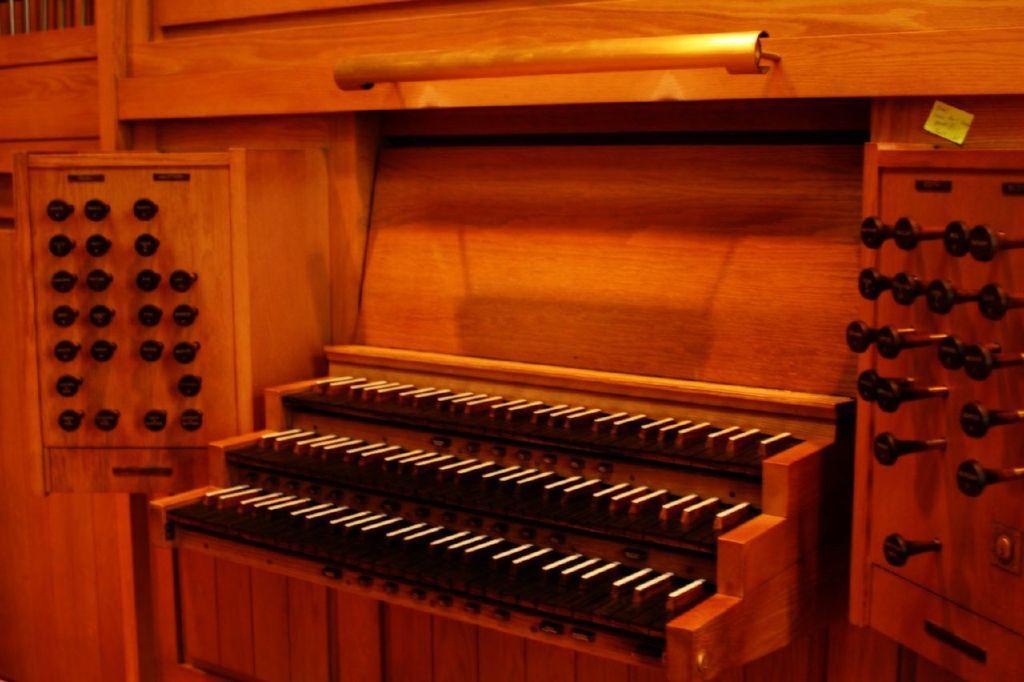In one or two sentences, can you explain what this image depicts? In this image in the center there is some object, and it looks like a table. On the table there are buttons, and on the right side and left side there is a board. On the board there are some objects, and in the background there is a wooden board and one pole and wall. 